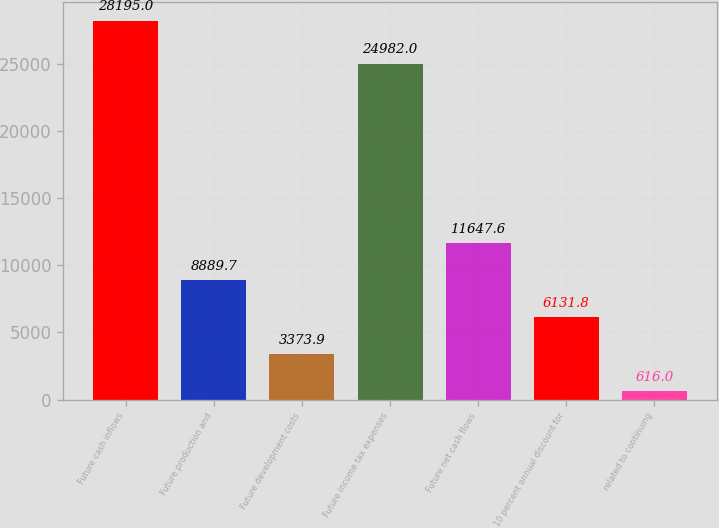Convert chart. <chart><loc_0><loc_0><loc_500><loc_500><bar_chart><fcel>Future cash inflows<fcel>Future production and<fcel>Future development costs<fcel>Future income tax expenses<fcel>Future net cash flows<fcel>10 percent annual discount for<fcel>related to continuing<nl><fcel>28195<fcel>8889.7<fcel>3373.9<fcel>24982<fcel>11647.6<fcel>6131.8<fcel>616<nl></chart> 